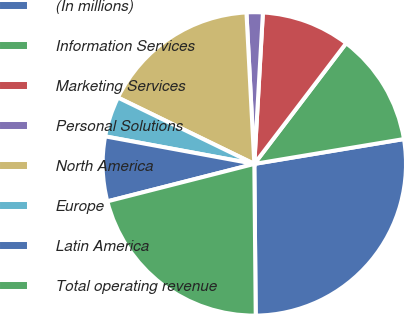Convert chart. <chart><loc_0><loc_0><loc_500><loc_500><pie_chart><fcel>(In millions)<fcel>Information Services<fcel>Marketing Services<fcel>Personal Solutions<fcel>North America<fcel>Europe<fcel>Latin America<fcel>Total operating revenue<nl><fcel>27.48%<fcel>12.03%<fcel>9.45%<fcel>1.73%<fcel>16.97%<fcel>4.3%<fcel>6.88%<fcel>21.18%<nl></chart> 